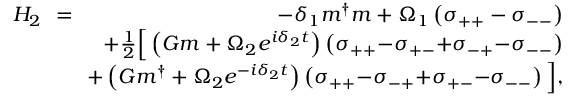Convert formula to latex. <formula><loc_0><loc_0><loc_500><loc_500>\begin{array} { r l r } { H _ { 2 } \, } & { = } & { \, - \delta _ { 1 } m ^ { \dag } m + \Omega _ { 1 } \left ( \sigma _ { + + } - \sigma _ { - - } \right ) } \\ & { \, + \frac { 1 } { 2 } \left [ \left ( G m + \Omega _ { 2 } e ^ { i \delta _ { 2 } t } \right ) \left ( \sigma _ { + + } { - } \sigma _ { + - } { + } \sigma _ { - + } { - } \sigma _ { - - } \right ) } \\ & { \, + \left ( G m ^ { \dag } + \Omega _ { 2 } e ^ { - i \delta _ { 2 } t } \right ) \left ( \sigma _ { + + } { - } \sigma _ { - + } { + } \sigma _ { + - } { - } \sigma _ { - - } \right ) \right ] , } \end{array}</formula> 